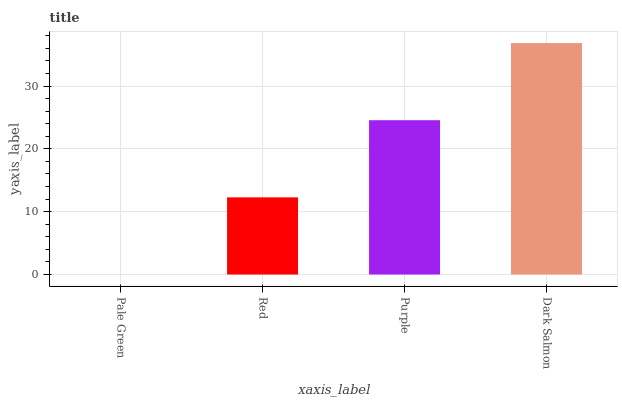Is Pale Green the minimum?
Answer yes or no. Yes. Is Dark Salmon the maximum?
Answer yes or no. Yes. Is Red the minimum?
Answer yes or no. No. Is Red the maximum?
Answer yes or no. No. Is Red greater than Pale Green?
Answer yes or no. Yes. Is Pale Green less than Red?
Answer yes or no. Yes. Is Pale Green greater than Red?
Answer yes or no. No. Is Red less than Pale Green?
Answer yes or no. No. Is Purple the high median?
Answer yes or no. Yes. Is Red the low median?
Answer yes or no. Yes. Is Red the high median?
Answer yes or no. No. Is Dark Salmon the low median?
Answer yes or no. No. 